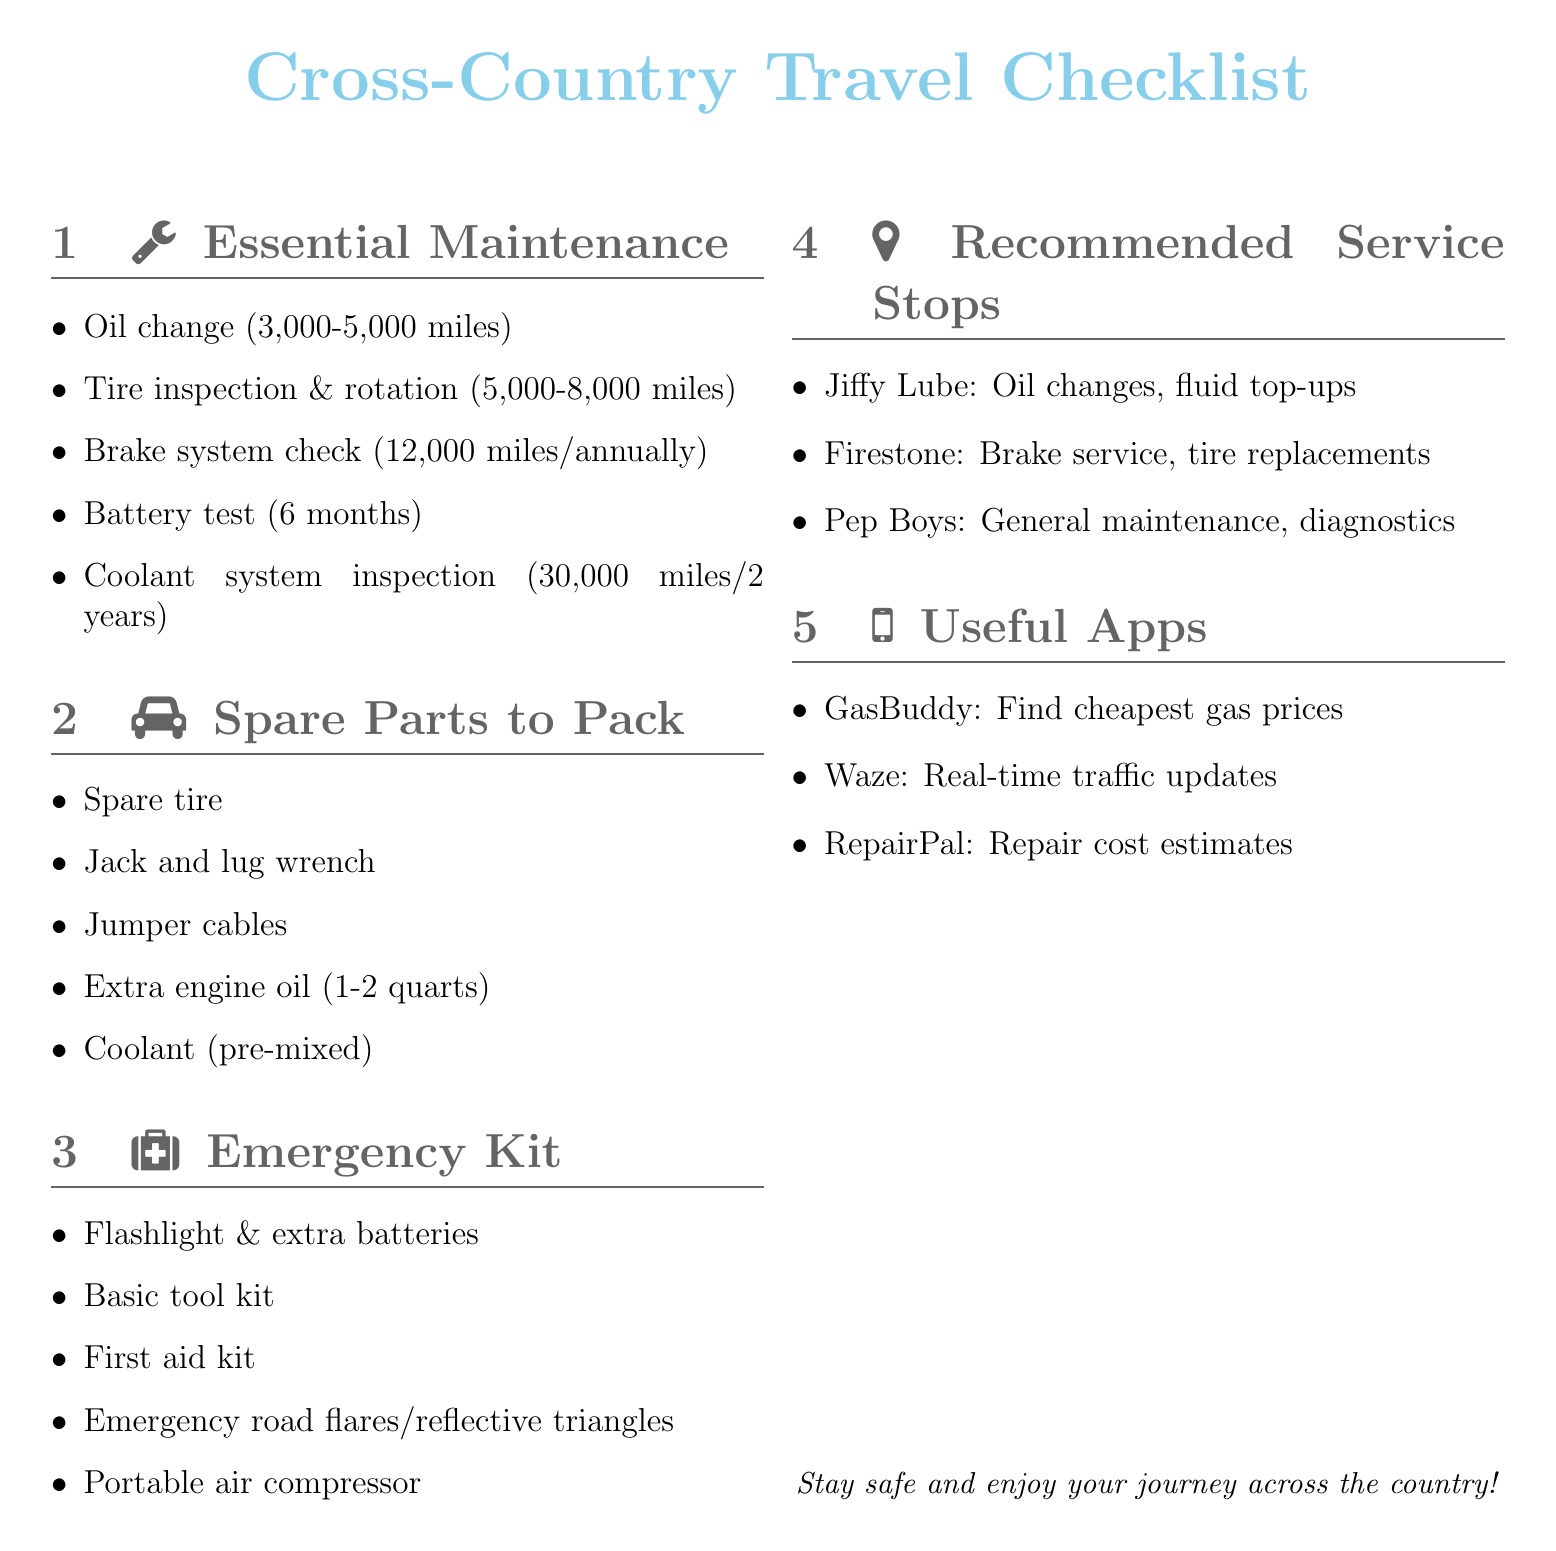What is the recommended interval for an oil change? The document states that an oil change is recommended every 3,000-5,000 miles or before a long trip.
Answer: Every 3,000-5,000 miles What is the importance of having a spare tire? The spare tire is categorized as critical for flat tire situations in the document.
Answer: Critical for flat tire situations How often should the brake system be checked? The document specifies that the brake system should be checked every 12,000 miles or annually.
Answer: Every 12,000 miles or annually What emergency kit item is essential for visibility? The emergency kit item specified for visibility is the flashlight and extra batteries.
Answer: Flashlight and extra batteries Which app helps find the cheapest gas prices? The document mentions GasBuddy as the app that finds the cheapest gas prices along your route.
Answer: GasBuddy 